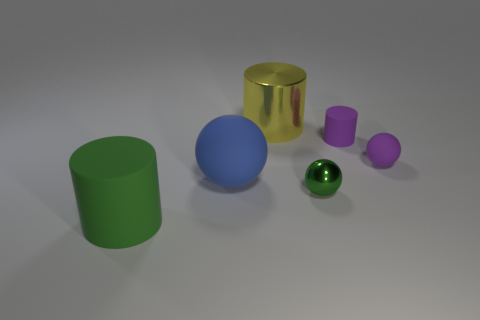The green shiny object has what shape?
Keep it short and to the point. Sphere. There is a tiny green thing; does it have the same shape as the matte object in front of the metal ball?
Offer a terse response. No. There is a large rubber thing that is on the right side of the green cylinder; is it the same shape as the big yellow thing?
Offer a terse response. No. What number of objects are left of the tiny green object and right of the big blue thing?
Your response must be concise. 1. Is the number of matte objects in front of the large blue sphere the same as the number of objects?
Your answer should be compact. No. There is a rubber cylinder behind the big blue matte thing; is it the same color as the large matte object that is behind the big green rubber cylinder?
Give a very brief answer. No. What is the material of the thing that is behind the tiny metal ball and left of the yellow cylinder?
Ensure brevity in your answer.  Rubber. The large metal thing is what color?
Your response must be concise. Yellow. What number of other objects are the same shape as the blue matte thing?
Make the answer very short. 2. Is the number of big blue things right of the big metal cylinder the same as the number of tiny purple rubber balls in front of the tiny green ball?
Your answer should be compact. Yes. 